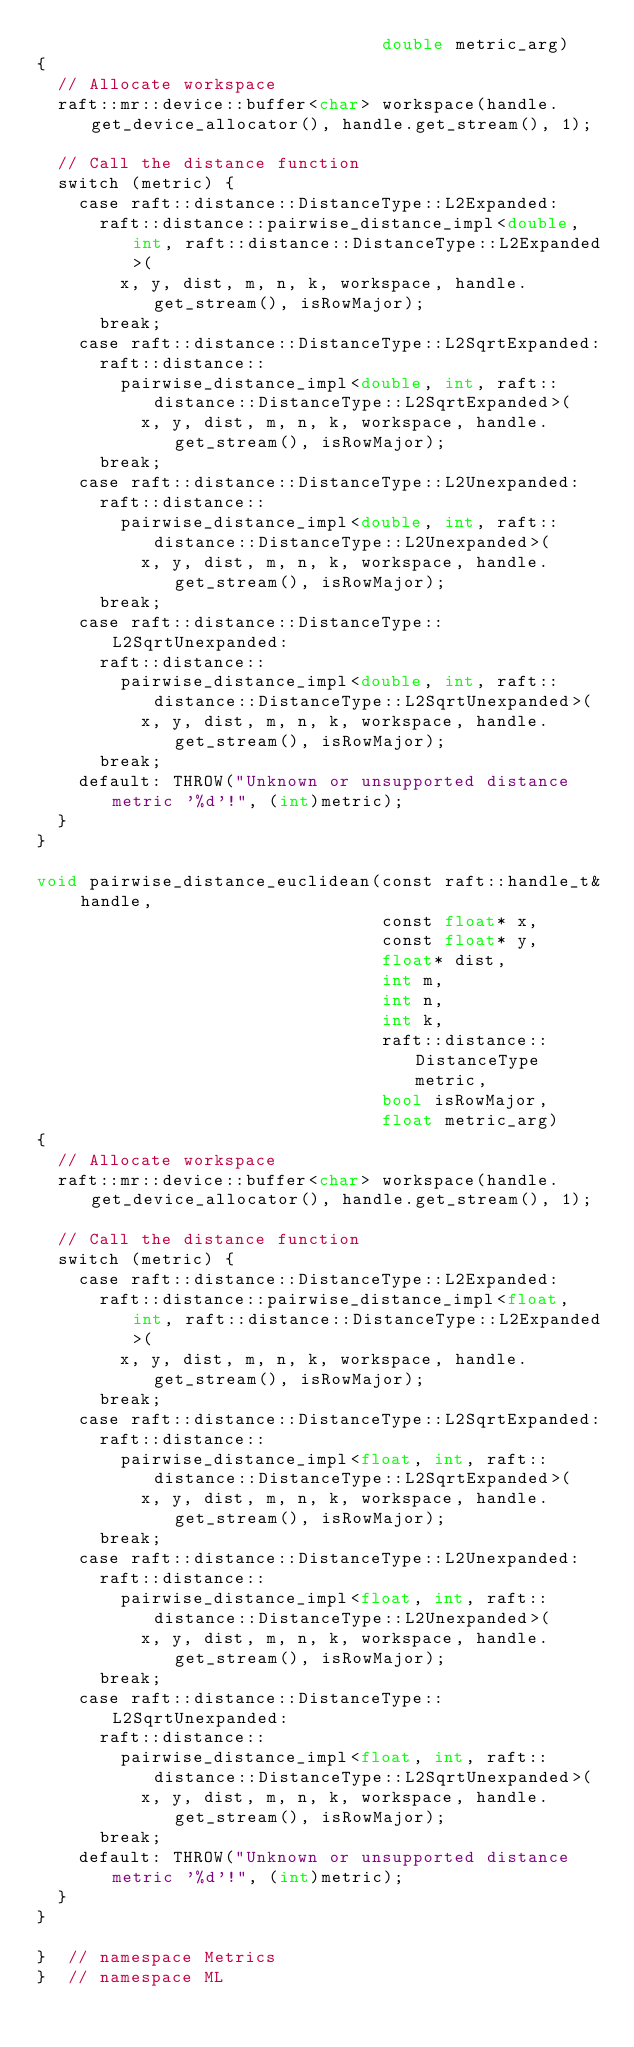Convert code to text. <code><loc_0><loc_0><loc_500><loc_500><_Cuda_>                                 double metric_arg)
{
  // Allocate workspace
  raft::mr::device::buffer<char> workspace(handle.get_device_allocator(), handle.get_stream(), 1);

  // Call the distance function
  switch (metric) {
    case raft::distance::DistanceType::L2Expanded:
      raft::distance::pairwise_distance_impl<double, int, raft::distance::DistanceType::L2Expanded>(
        x, y, dist, m, n, k, workspace, handle.get_stream(), isRowMajor);
      break;
    case raft::distance::DistanceType::L2SqrtExpanded:
      raft::distance::
        pairwise_distance_impl<double, int, raft::distance::DistanceType::L2SqrtExpanded>(
          x, y, dist, m, n, k, workspace, handle.get_stream(), isRowMajor);
      break;
    case raft::distance::DistanceType::L2Unexpanded:
      raft::distance::
        pairwise_distance_impl<double, int, raft::distance::DistanceType::L2Unexpanded>(
          x, y, dist, m, n, k, workspace, handle.get_stream(), isRowMajor);
      break;
    case raft::distance::DistanceType::L2SqrtUnexpanded:
      raft::distance::
        pairwise_distance_impl<double, int, raft::distance::DistanceType::L2SqrtUnexpanded>(
          x, y, dist, m, n, k, workspace, handle.get_stream(), isRowMajor);
      break;
    default: THROW("Unknown or unsupported distance metric '%d'!", (int)metric);
  }
}

void pairwise_distance_euclidean(const raft::handle_t& handle,
                                 const float* x,
                                 const float* y,
                                 float* dist,
                                 int m,
                                 int n,
                                 int k,
                                 raft::distance::DistanceType metric,
                                 bool isRowMajor,
                                 float metric_arg)
{
  // Allocate workspace
  raft::mr::device::buffer<char> workspace(handle.get_device_allocator(), handle.get_stream(), 1);

  // Call the distance function
  switch (metric) {
    case raft::distance::DistanceType::L2Expanded:
      raft::distance::pairwise_distance_impl<float, int, raft::distance::DistanceType::L2Expanded>(
        x, y, dist, m, n, k, workspace, handle.get_stream(), isRowMajor);
      break;
    case raft::distance::DistanceType::L2SqrtExpanded:
      raft::distance::
        pairwise_distance_impl<float, int, raft::distance::DistanceType::L2SqrtExpanded>(
          x, y, dist, m, n, k, workspace, handle.get_stream(), isRowMajor);
      break;
    case raft::distance::DistanceType::L2Unexpanded:
      raft::distance::
        pairwise_distance_impl<float, int, raft::distance::DistanceType::L2Unexpanded>(
          x, y, dist, m, n, k, workspace, handle.get_stream(), isRowMajor);
      break;
    case raft::distance::DistanceType::L2SqrtUnexpanded:
      raft::distance::
        pairwise_distance_impl<float, int, raft::distance::DistanceType::L2SqrtUnexpanded>(
          x, y, dist, m, n, k, workspace, handle.get_stream(), isRowMajor);
      break;
    default: THROW("Unknown or unsupported distance metric '%d'!", (int)metric);
  }
}

}  // namespace Metrics
}  // namespace ML
</code> 